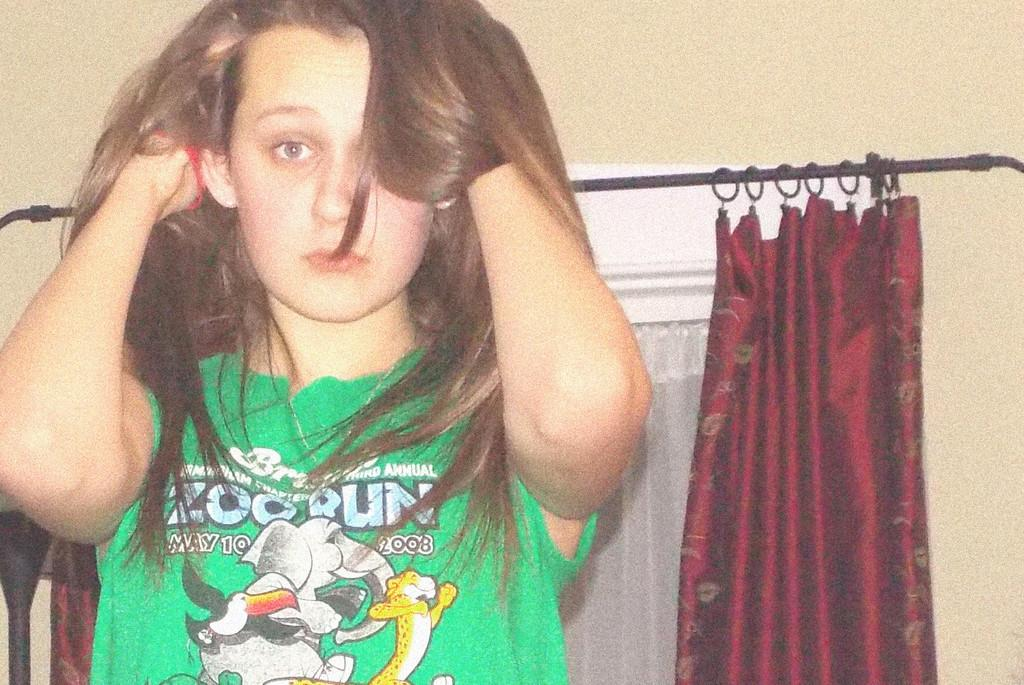Who is present in the image? There is a woman in the image. What is the woman wearing? The woman is wearing a green T-shirt. What is the woman doing with her hands? The woman has both hands in her hair. What can be seen in the background of the image? There are red color curtains and a wall visible in the background. What type of instrument is the woman playing in the image? There is no instrument present in the image; the woman has both hands in her hair. What is the temperature in the room where the image was taken? The temperature cannot be determined from the image, as there is no information about the room's temperature provided. 